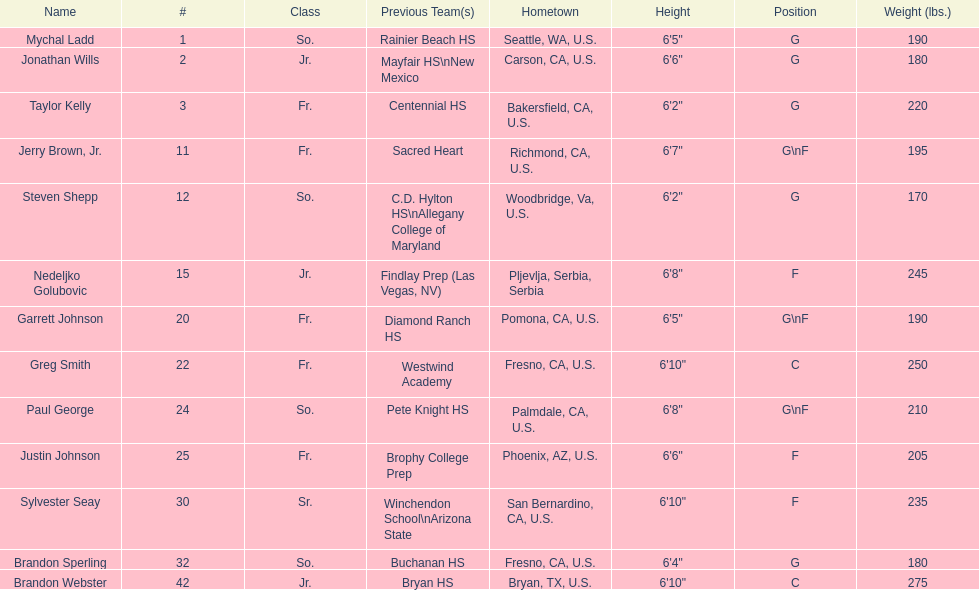Which positions are so.? G, G, G\nF, G. Which weights are g 190, 170, 180. What height is under 6 3' 6'2". What is the name Steven Shepp. 